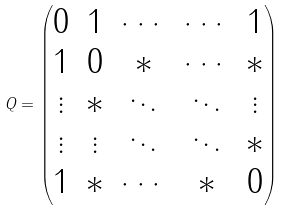<formula> <loc_0><loc_0><loc_500><loc_500>Q = \begin{pmatrix} 0 & 1 & \cdots & \cdots & 1 \\ 1 & 0 & * & \cdots & * \\ \vdots & * & \ddots & \ddots & \vdots \\ \vdots & \vdots & \ddots & \ddots & * \\ 1 & * & \cdots & * & 0 \end{pmatrix}</formula> 